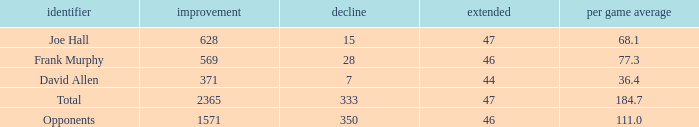Which Avg/G has a Name of david allen, and a Gain larger than 371? None. 